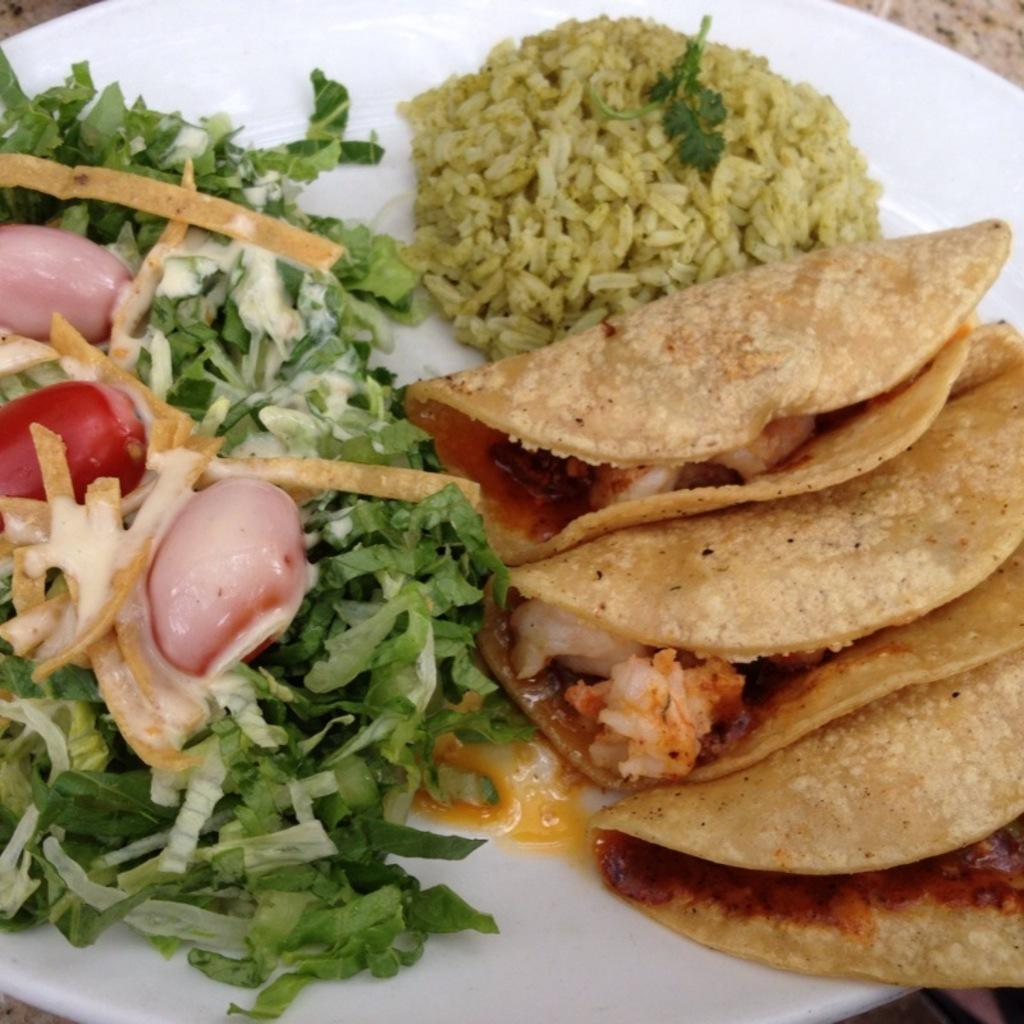What type of food can be seen in the image? The image contains rice, vegetables, and snacks. How are the food items arranged in the image? The food items are arranged on a white plate. What type of honey can be seen drizzled over the vegetables in the image? There is no honey present in the image; it features rice, vegetables, and snacks arranged on a white plate. 